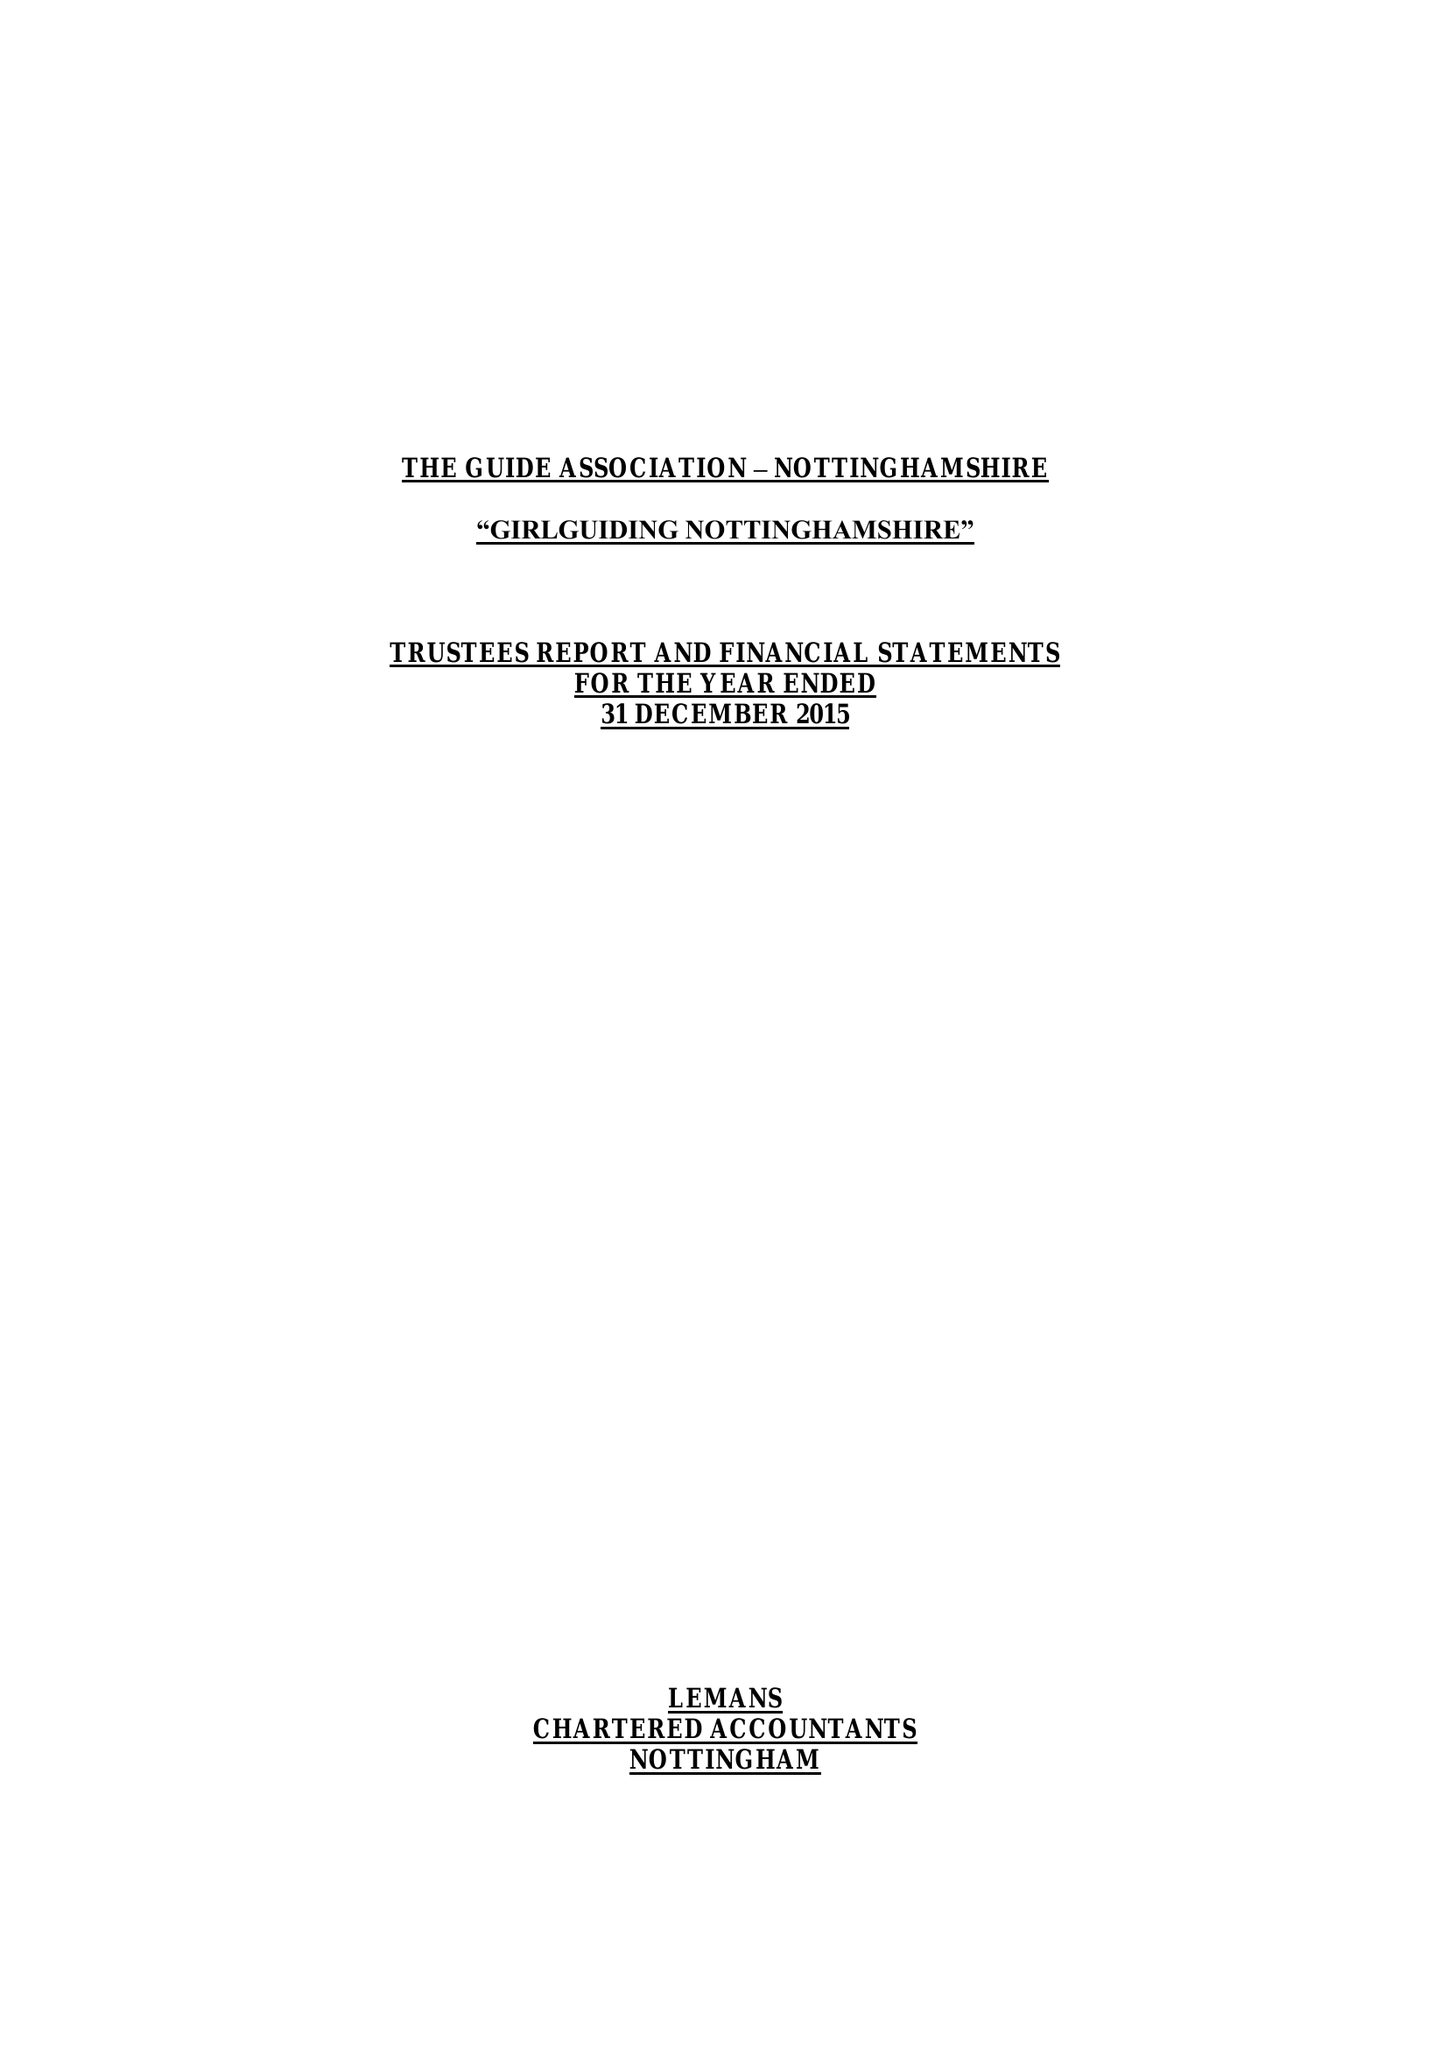What is the value for the report_date?
Answer the question using a single word or phrase. 2015-12-31 